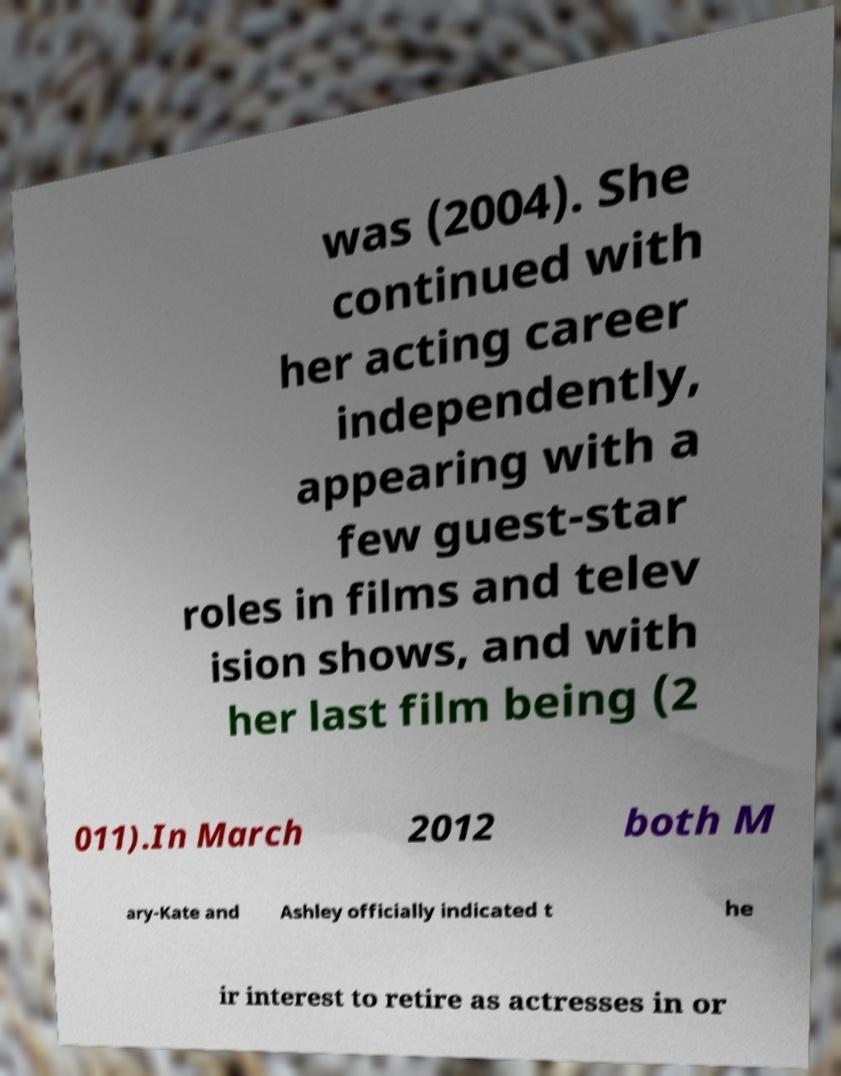Can you read and provide the text displayed in the image?This photo seems to have some interesting text. Can you extract and type it out for me? was (2004). She continued with her acting career independently, appearing with a few guest-star roles in films and telev ision shows, and with her last film being (2 011).In March 2012 both M ary-Kate and Ashley officially indicated t he ir interest to retire as actresses in or 